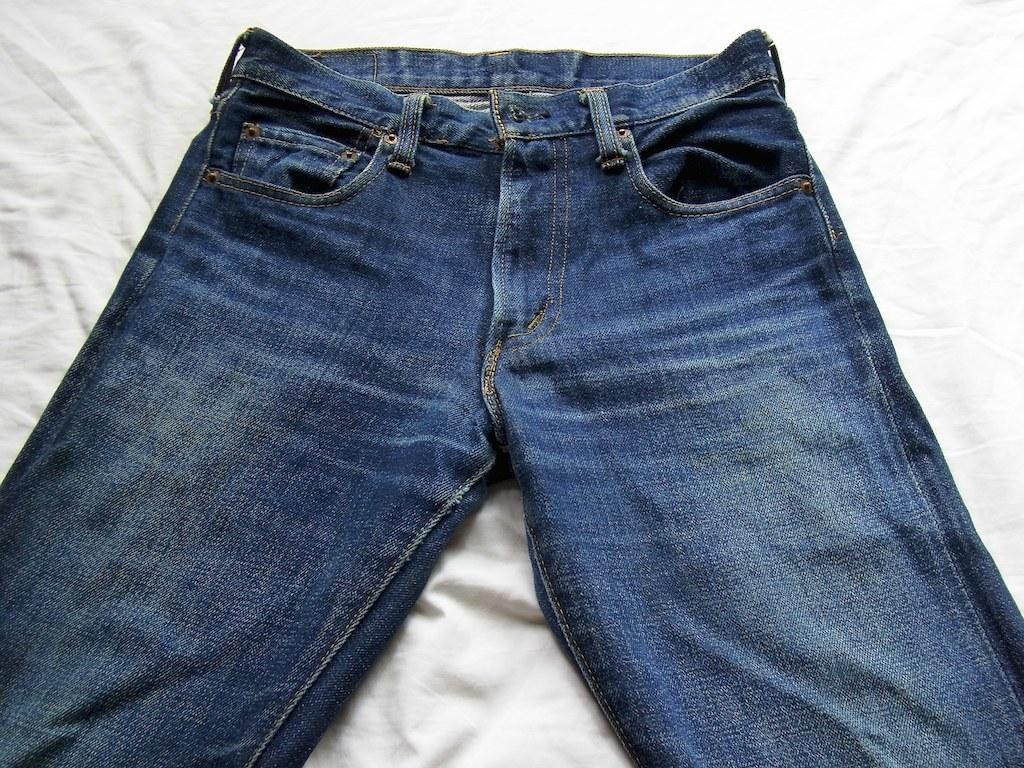Could you give a brief overview of what you see in this image? In this image I can see the pant in blue color and the pant is on the white color cloth. 